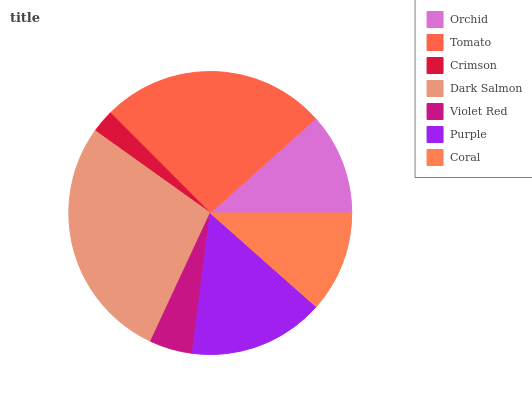Is Crimson the minimum?
Answer yes or no. Yes. Is Dark Salmon the maximum?
Answer yes or no. Yes. Is Tomato the minimum?
Answer yes or no. No. Is Tomato the maximum?
Answer yes or no. No. Is Tomato greater than Orchid?
Answer yes or no. Yes. Is Orchid less than Tomato?
Answer yes or no. Yes. Is Orchid greater than Tomato?
Answer yes or no. No. Is Tomato less than Orchid?
Answer yes or no. No. Is Orchid the high median?
Answer yes or no. Yes. Is Orchid the low median?
Answer yes or no. Yes. Is Tomato the high median?
Answer yes or no. No. Is Tomato the low median?
Answer yes or no. No. 